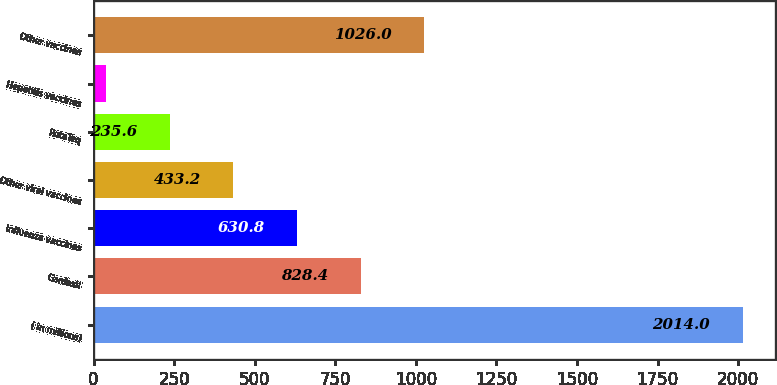Convert chart to OTSL. <chart><loc_0><loc_0><loc_500><loc_500><bar_chart><fcel>( in millions)<fcel>Gardasil<fcel>Influenza vaccines<fcel>Other viral vaccines<fcel>RotaTeq<fcel>Hepatitis vaccines<fcel>Other vaccines<nl><fcel>2014<fcel>828.4<fcel>630.8<fcel>433.2<fcel>235.6<fcel>38<fcel>1026<nl></chart> 